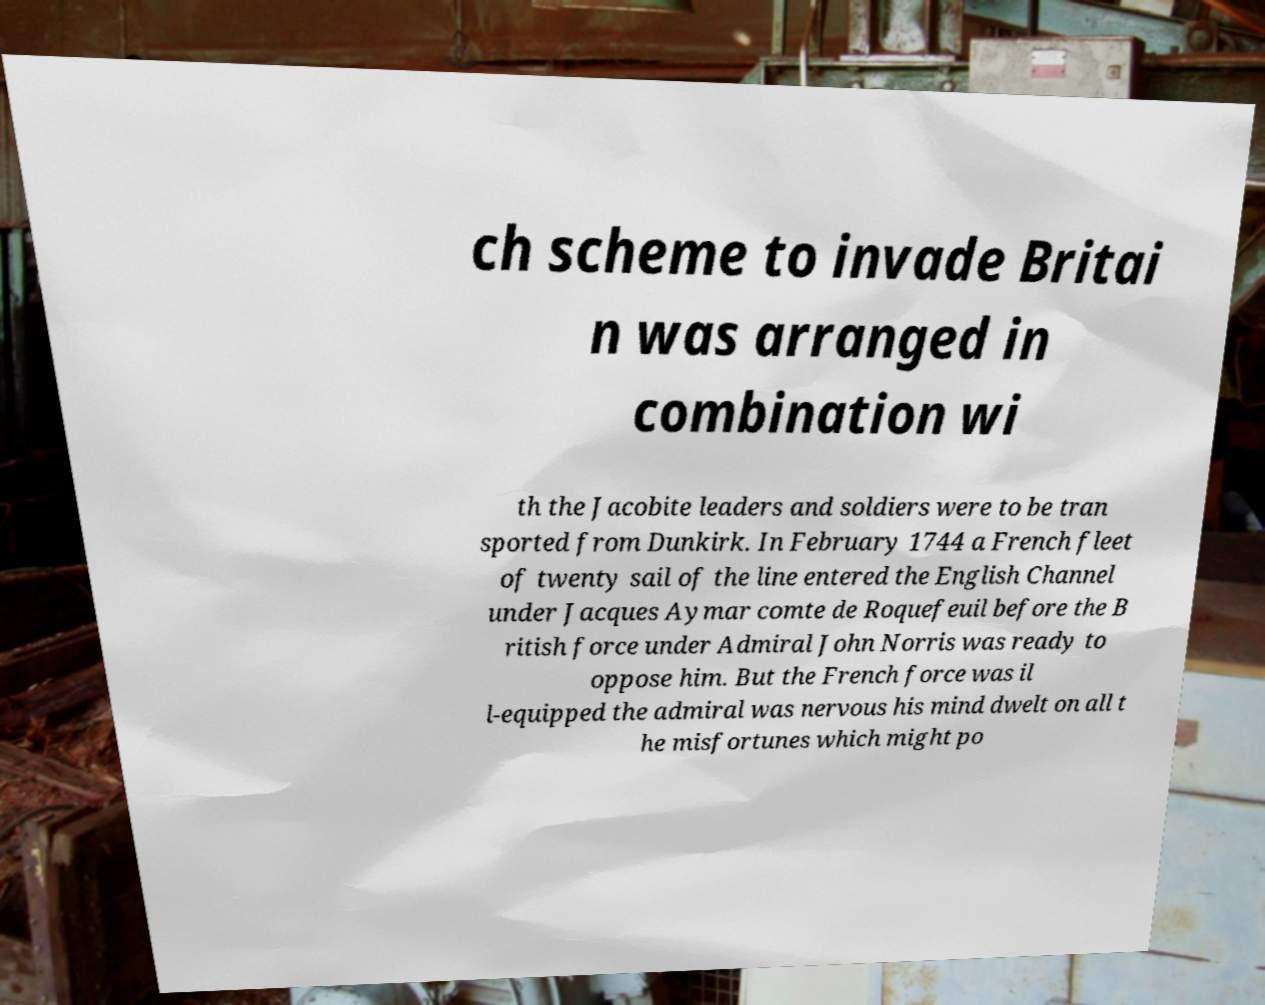For documentation purposes, I need the text within this image transcribed. Could you provide that? ch scheme to invade Britai n was arranged in combination wi th the Jacobite leaders and soldiers were to be tran sported from Dunkirk. In February 1744 a French fleet of twenty sail of the line entered the English Channel under Jacques Aymar comte de Roquefeuil before the B ritish force under Admiral John Norris was ready to oppose him. But the French force was il l-equipped the admiral was nervous his mind dwelt on all t he misfortunes which might po 